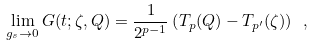<formula> <loc_0><loc_0><loc_500><loc_500>\lim _ { g _ { s } \to 0 } G ( t ; \zeta , Q ) = \frac { 1 } { 2 ^ { p - 1 } } \left ( T _ { p } ( Q ) - T _ { p ^ { \prime } } ( \zeta ) \right ) \ ,</formula> 